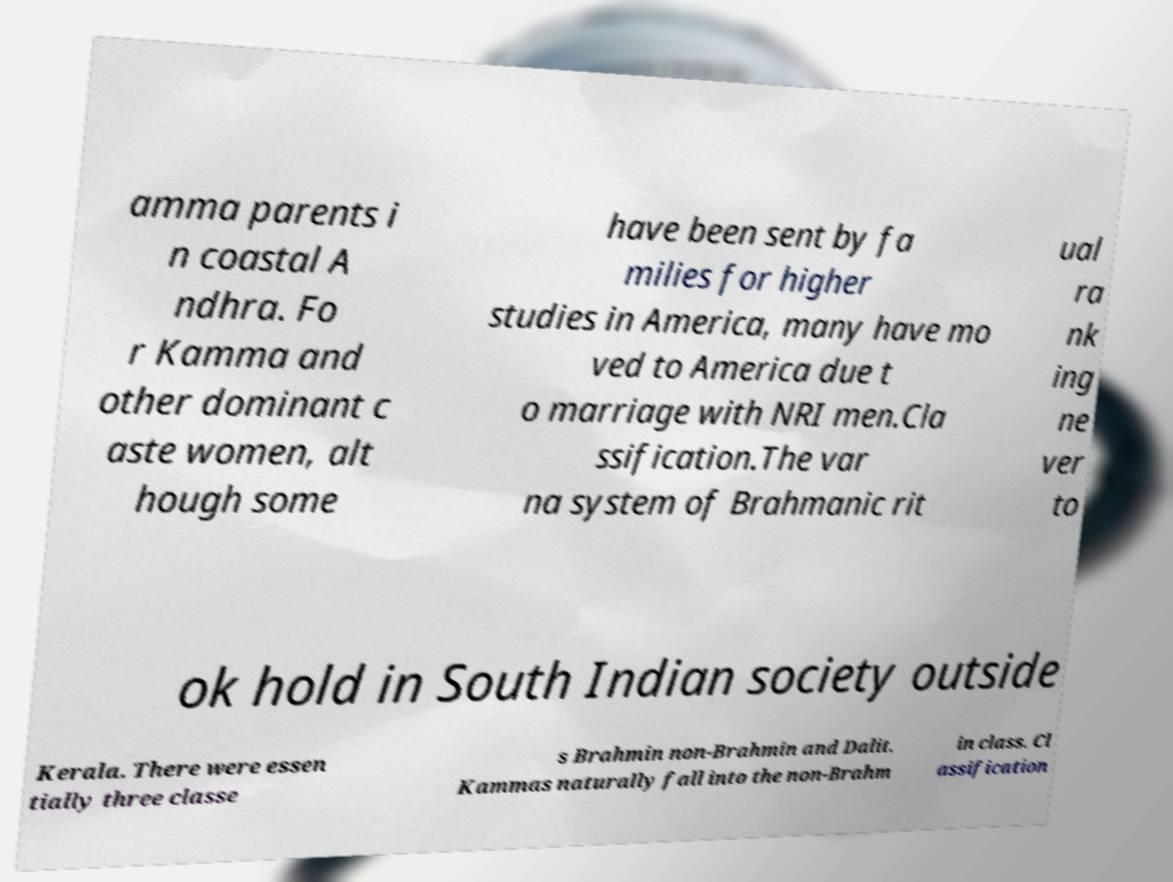Can you accurately transcribe the text from the provided image for me? amma parents i n coastal A ndhra. Fo r Kamma and other dominant c aste women, alt hough some have been sent by fa milies for higher studies in America, many have mo ved to America due t o marriage with NRI men.Cla ssification.The var na system of Brahmanic rit ual ra nk ing ne ver to ok hold in South Indian society outside Kerala. There were essen tially three classe s Brahmin non-Brahmin and Dalit. Kammas naturally fall into the non-Brahm in class. Cl assification 